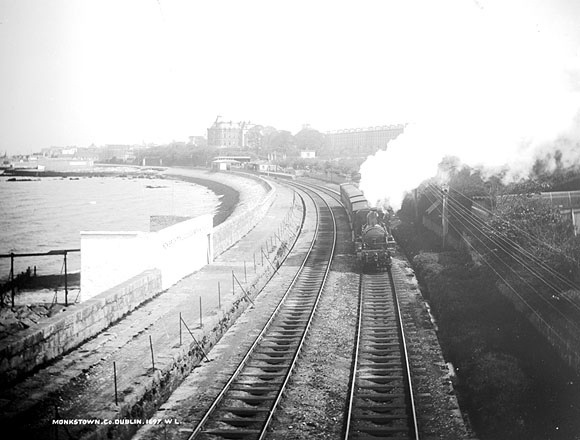Describe the objects in this image and their specific colors. I can see a train in lightgray, gray, darkgray, and black tones in this image. 